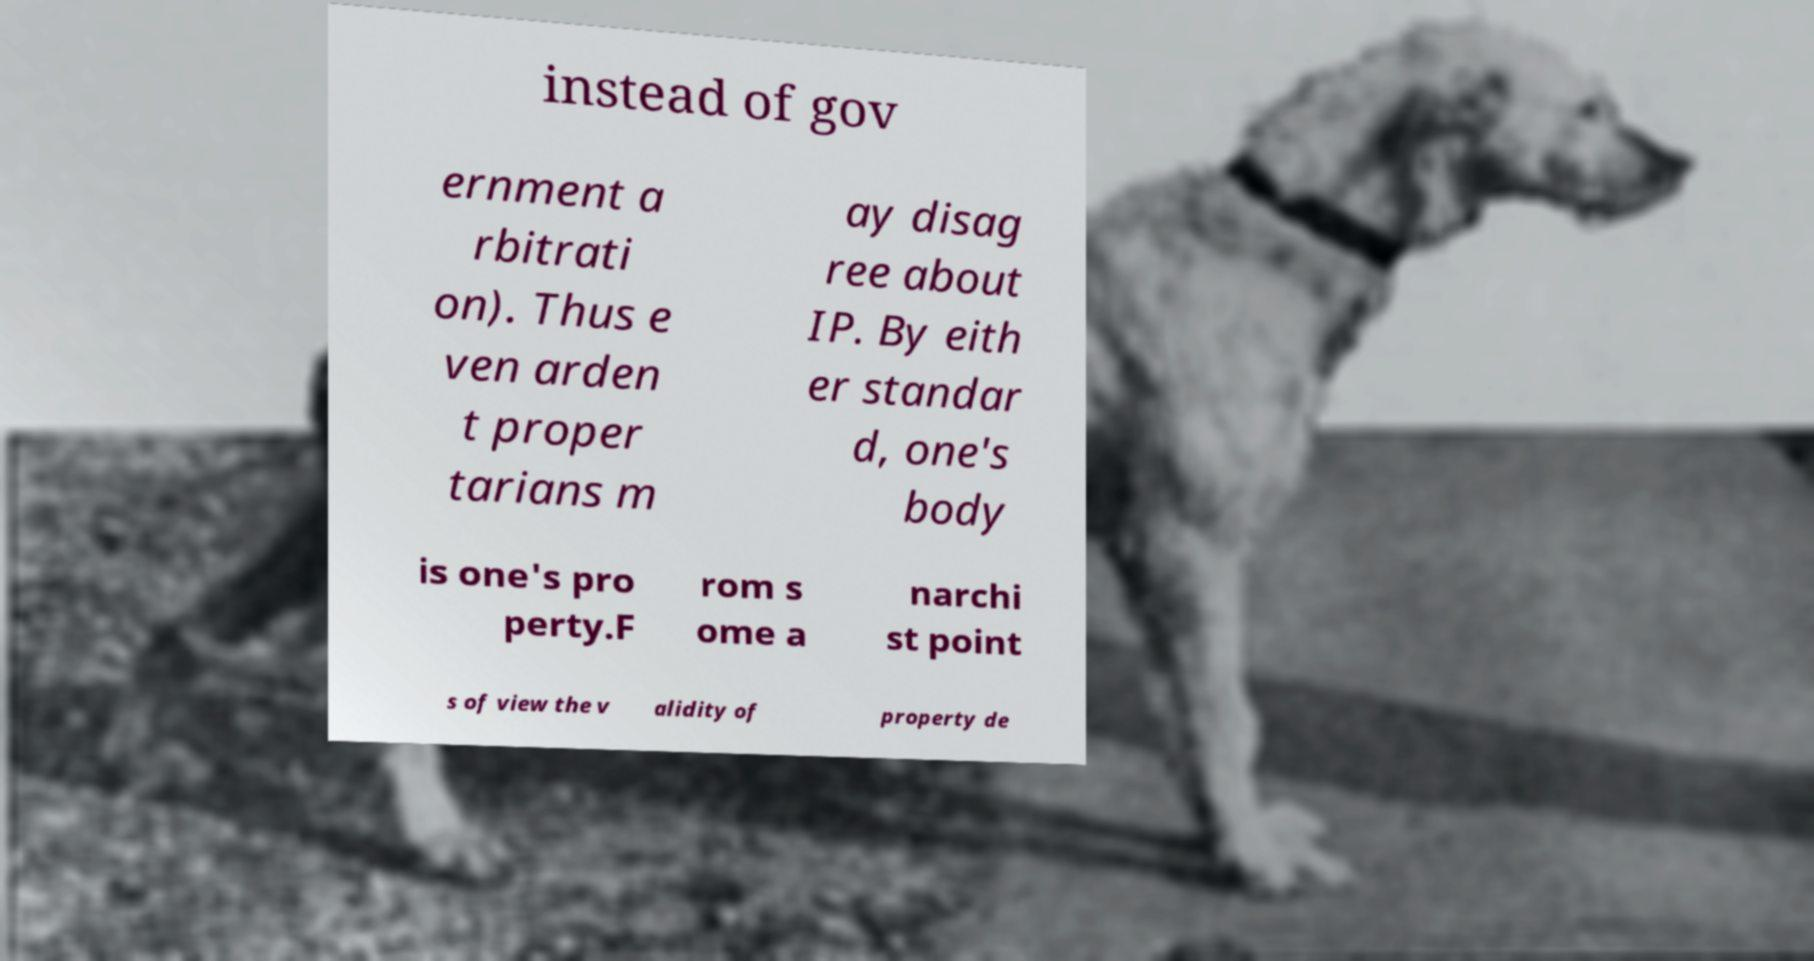Please identify and transcribe the text found in this image. instead of gov ernment a rbitrati on). Thus e ven arden t proper tarians m ay disag ree about IP. By eith er standar d, one's body is one's pro perty.F rom s ome a narchi st point s of view the v alidity of property de 